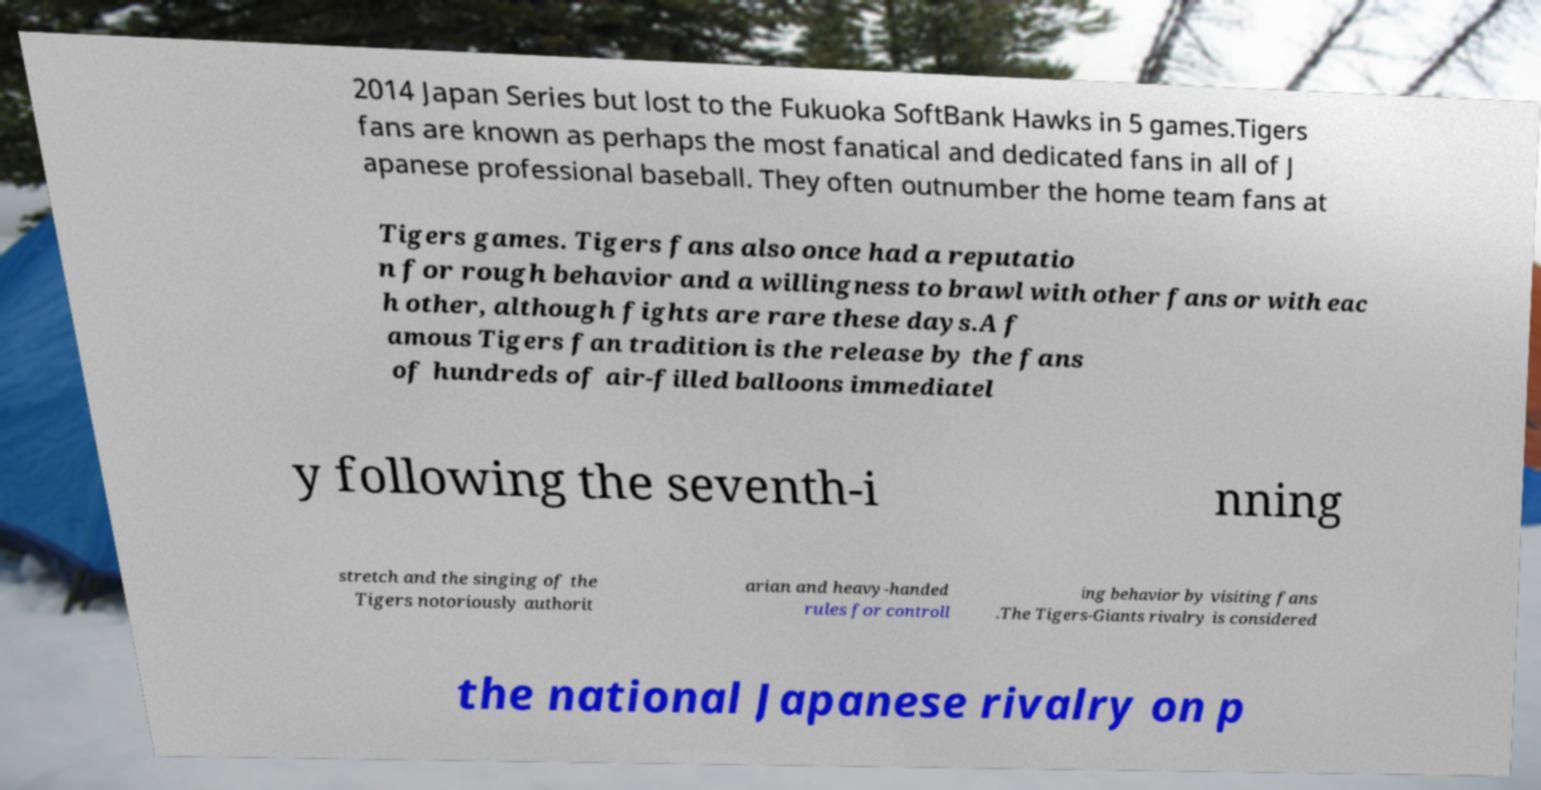Could you extract and type out the text from this image? 2014 Japan Series but lost to the Fukuoka SoftBank Hawks in 5 games.Tigers fans are known as perhaps the most fanatical and dedicated fans in all of J apanese professional baseball. They often outnumber the home team fans at Tigers games. Tigers fans also once had a reputatio n for rough behavior and a willingness to brawl with other fans or with eac h other, although fights are rare these days.A f amous Tigers fan tradition is the release by the fans of hundreds of air-filled balloons immediatel y following the seventh-i nning stretch and the singing of the Tigers notoriously authorit arian and heavy-handed rules for controll ing behavior by visiting fans .The Tigers-Giants rivalry is considered the national Japanese rivalry on p 